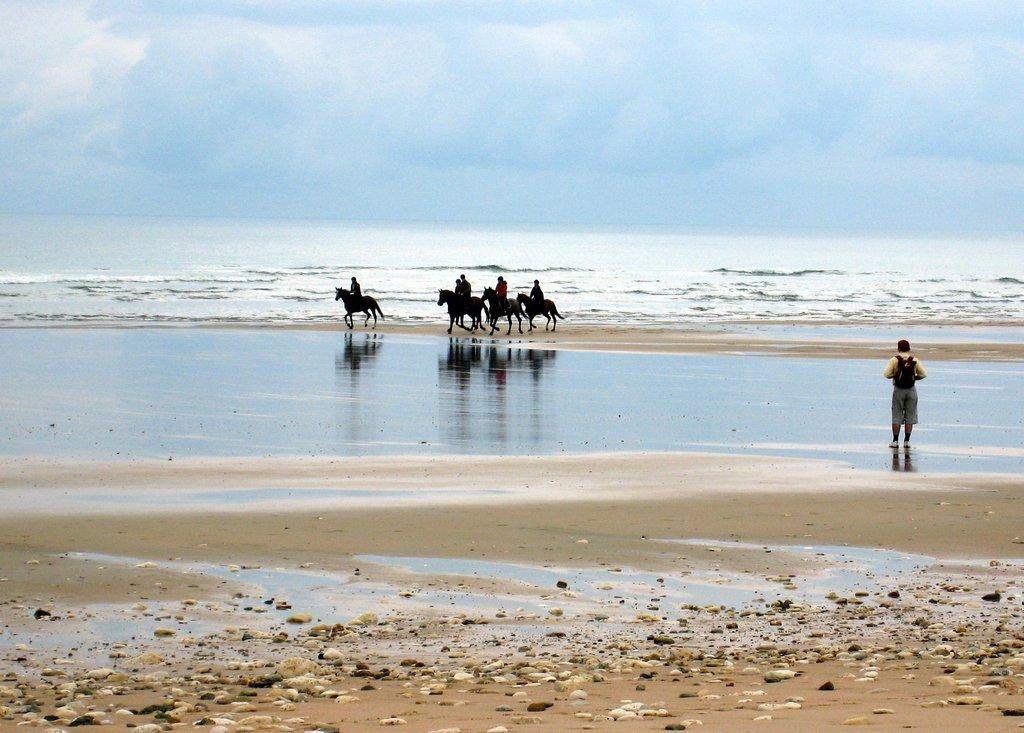What are the people in the image doing? The people in the image are riding horses. Where are the horses located in the image? The horses are on the seashore. Can you describe the person standing in the image? There is a person standing in the image, but their specific appearance or actions are not mentioned in the facts. What can be seen in the background of the image? There is a river and the sky visible in the background of the image. What type of sweater is the person wearing in the lunchroom in the image? There is no lunchroom or sweater mentioned in the image. The image features people riding horses on the seashore, with a river and the sky visible in the background. 